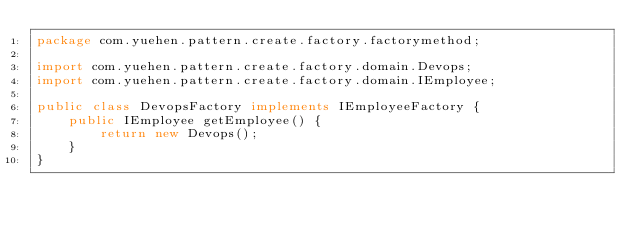<code> <loc_0><loc_0><loc_500><loc_500><_Java_>package com.yuehen.pattern.create.factory.factorymethod;

import com.yuehen.pattern.create.factory.domain.Devops;
import com.yuehen.pattern.create.factory.domain.IEmployee;

public class DevopsFactory implements IEmployeeFactory {
    public IEmployee getEmployee() {
        return new Devops();
    }
}
</code> 